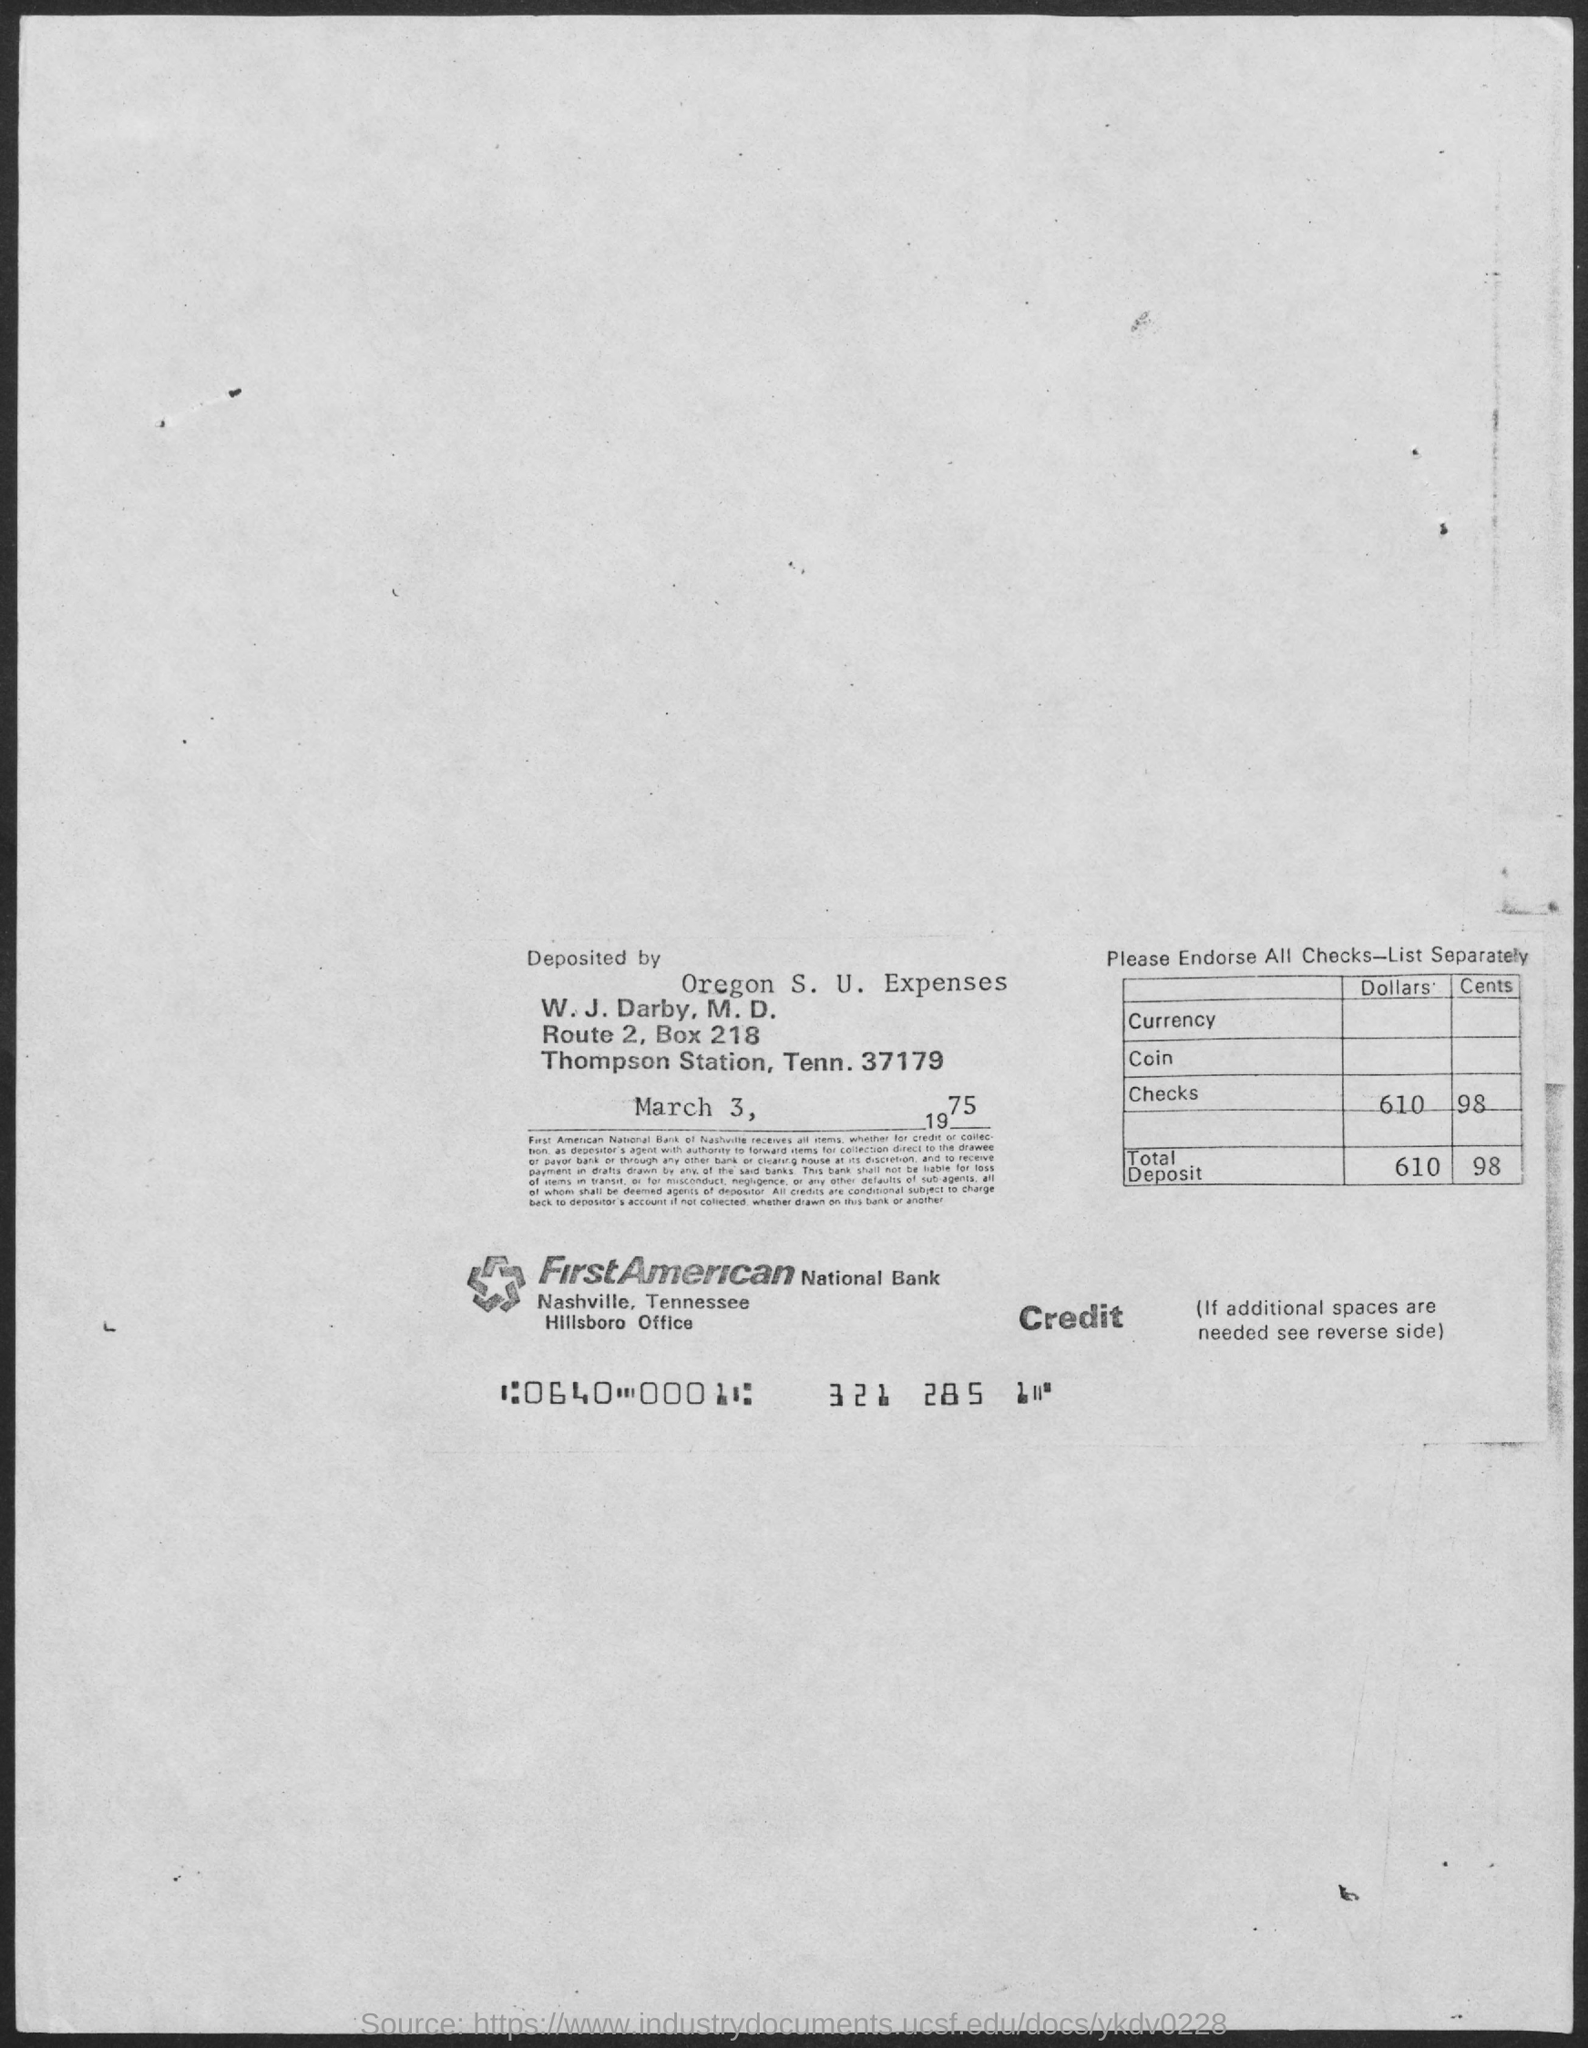What is the date mentioned in the document?
Keep it short and to the point. March 3, 1975. 